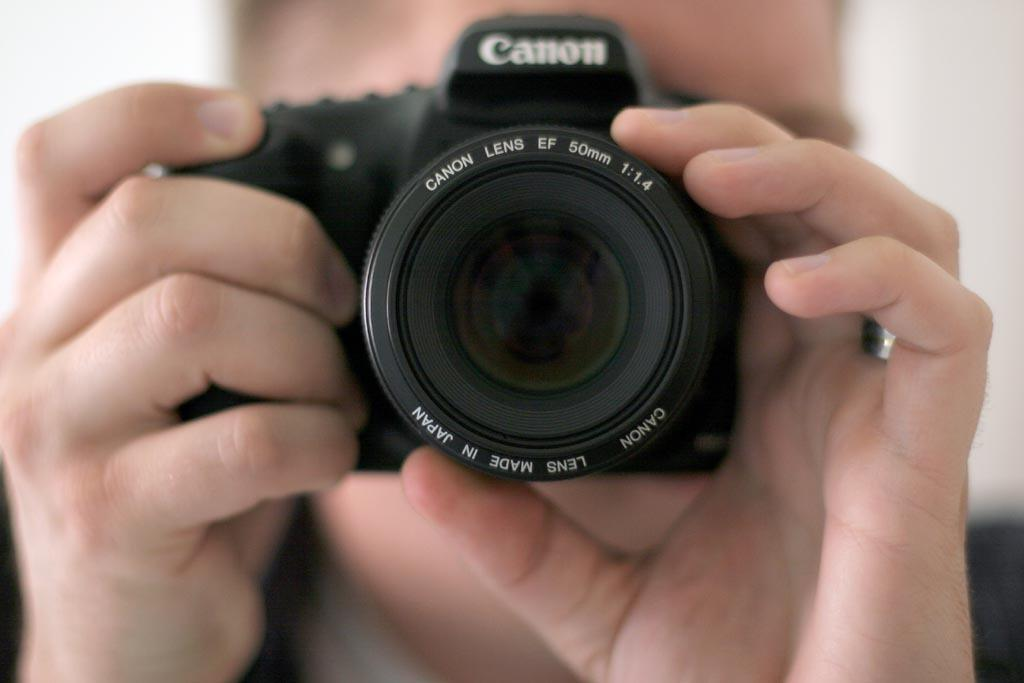What is the main subject of the image? There is a person in the image. What is the person holding in the image? The person is holding a camera. What is the color of the camera? The camera is black in color. What is the color of the background in the image? The background of the image is white. Can you tell me how many vases are visible in the image? There are no vases present in the image. What type of joke is being told by the person in the image? There is no indication of a joke being told in the image. 